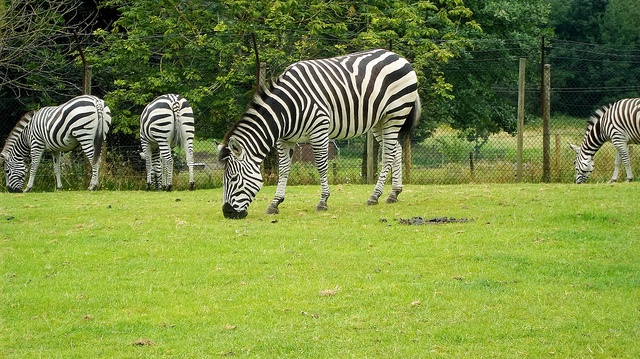Describe the objects in this image and their specific colors. I can see zebra in olive, black, ivory, gray, and darkgray tones, zebra in olive, black, gray, lightgray, and darkgray tones, zebra in olive, ivory, darkgray, gray, and black tones, and zebra in olive, black, darkgray, and gray tones in this image. 